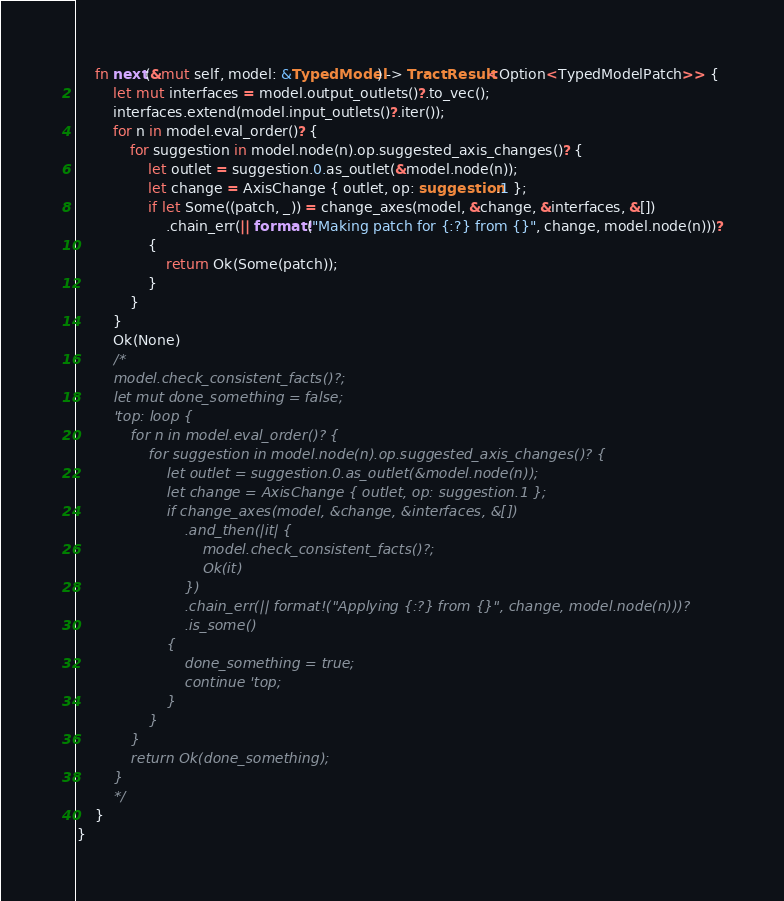Convert code to text. <code><loc_0><loc_0><loc_500><loc_500><_Rust_>    fn next(&mut self, model: &TypedModel) -> TractResult<Option<TypedModelPatch>> {
        let mut interfaces = model.output_outlets()?.to_vec();
        interfaces.extend(model.input_outlets()?.iter());
        for n in model.eval_order()? {
            for suggestion in model.node(n).op.suggested_axis_changes()? {
                let outlet = suggestion.0.as_outlet(&model.node(n));
                let change = AxisChange { outlet, op: suggestion.1 };
                if let Some((patch, _)) = change_axes(model, &change, &interfaces, &[])
                    .chain_err(|| format!("Making patch for {:?} from {}", change, model.node(n)))?
                {
                    return Ok(Some(patch));
                }
            }
        }
        Ok(None)
        /*
        model.check_consistent_facts()?;
        let mut done_something = false;
        'top: loop {
            for n in model.eval_order()? {
                for suggestion in model.node(n).op.suggested_axis_changes()? {
                    let outlet = suggestion.0.as_outlet(&model.node(n));
                    let change = AxisChange { outlet, op: suggestion.1 };
                    if change_axes(model, &change, &interfaces, &[])
                        .and_then(|it| {
                            model.check_consistent_facts()?;
                            Ok(it)
                        })
                        .chain_err(|| format!("Applying {:?} from {}", change, model.node(n)))?
                        .is_some()
                    {
                        done_something = true;
                        continue 'top;
                    }
                }
            }
            return Ok(done_something);
        }
        */
    }
}
</code> 